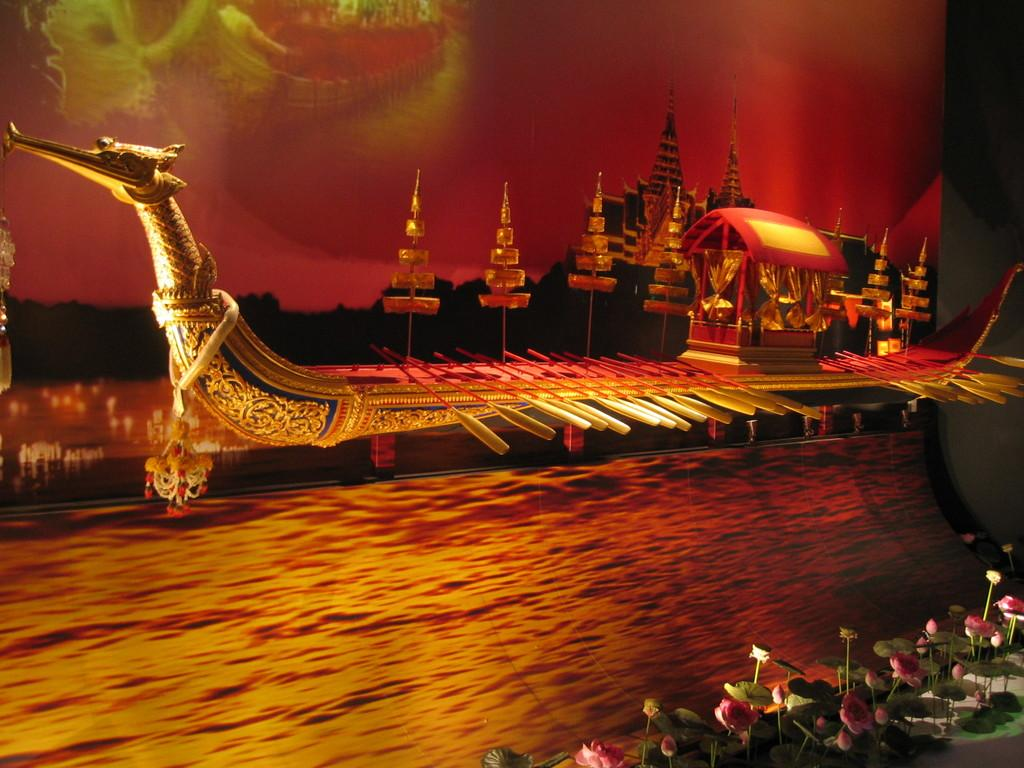What can be observed about the image that suggests it has been edited? The image appears to be edited, as it contains elements that may not be naturally occurring together, such as a flying board. What is located at the bottom of the image? There is water at the bottom of the image. What is the main object in the front of the image? There is a flying board in the front of the image. What type of vegetation can be seen in the background of the image? There are trees in the background of the image. What type of structure is visible in the background of the image? There is a castle in the background of the image. What type of needle is being used to sew the hall in the image? There is no needle or hall present in the image; it features a flying board, water, trees, and a castle. 